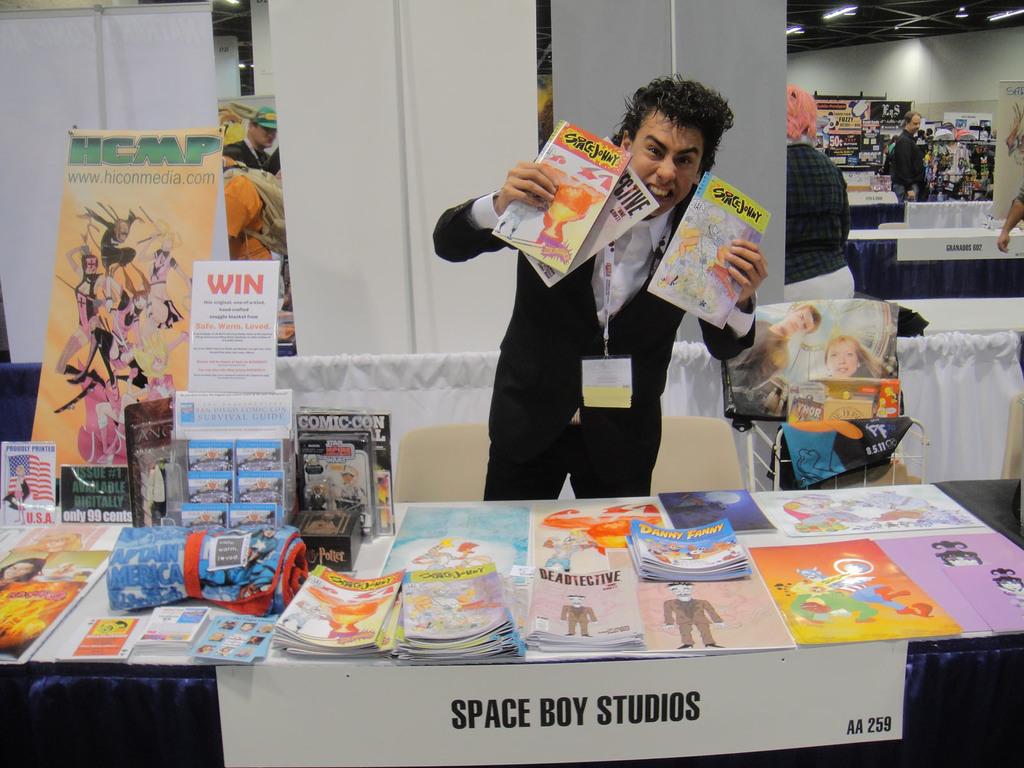What studios are the comics from?
Your answer should be compact. Space boy. What's written in orange on the white poster?
Provide a short and direct response. Win. 